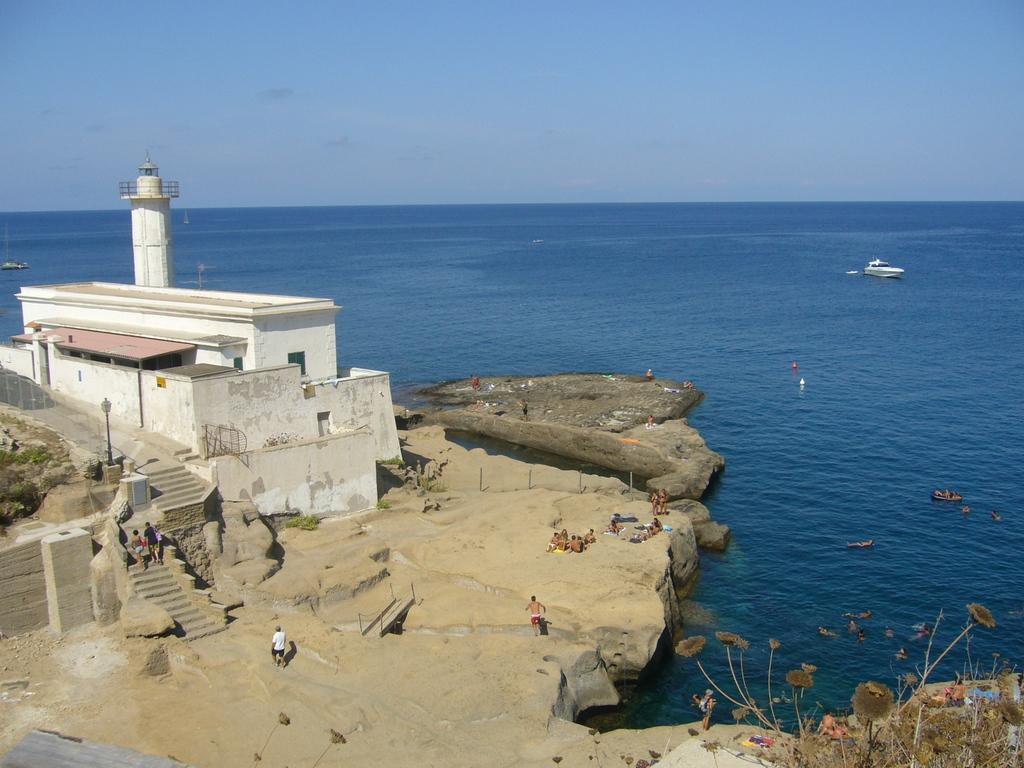What is the main feature of the image? There is water in the image. What type of structure can be seen in the image? There is a house in the image. Can you describe the people in the image? There are people in the image. What architectural element is present in the image? There are steps in the image. What type of vegetation is visible in the image? There is grass and plants in the image. What mode of transportation is present in the image? There is a boat in the image. What can be seen in the background of the image? The sky is visible in the background of the image. What type of owl can be seen perched on the house in the image? There is no owl present in the image; it only features a house, water, people, steps, grass, plants, a boat, and the sky. What material is the brass used for in the image? There is no brass present in the image. 